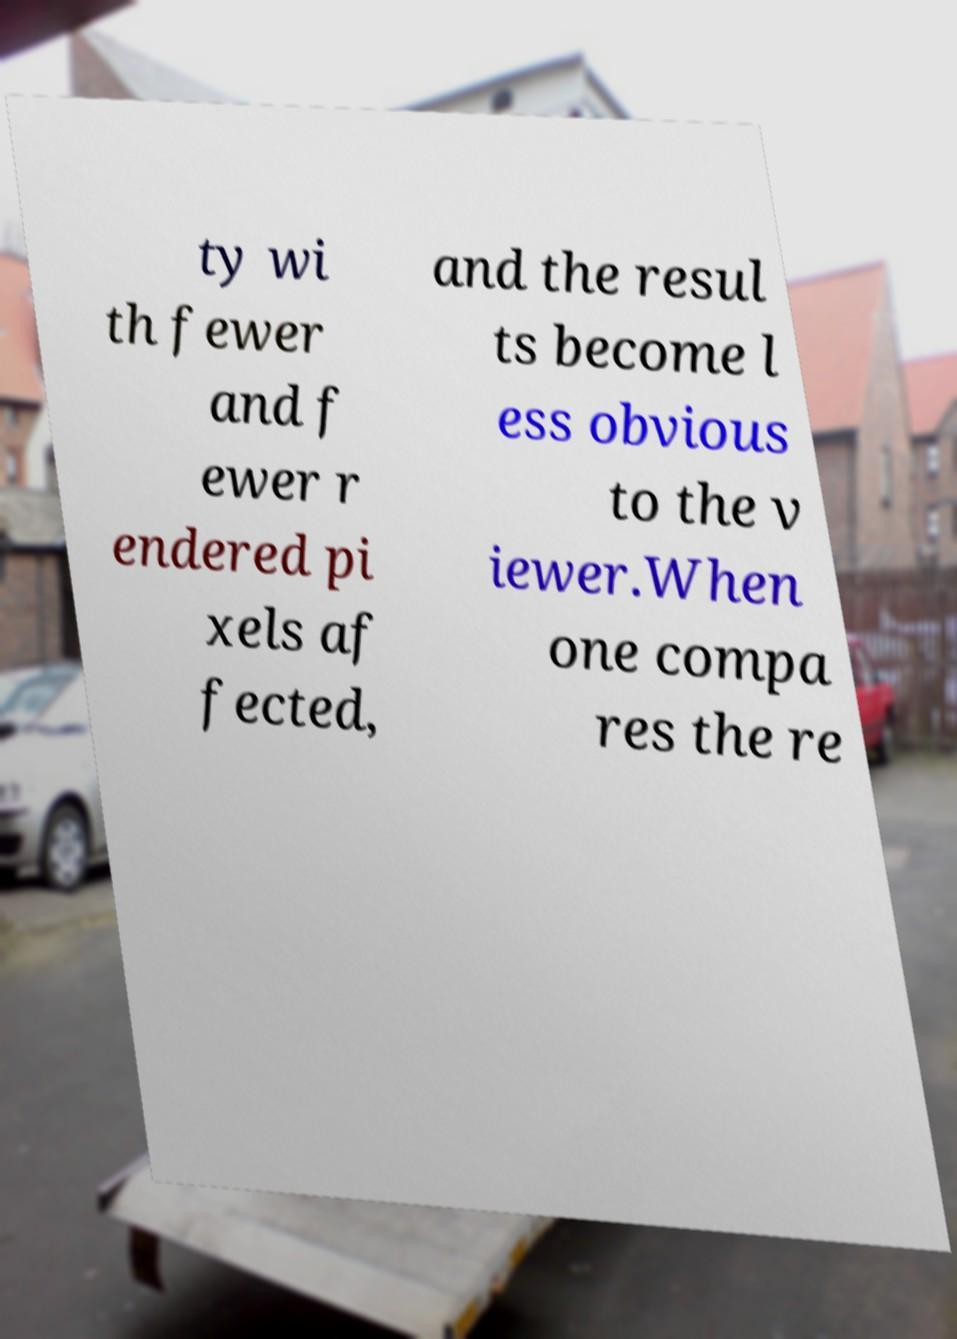Can you read and provide the text displayed in the image?This photo seems to have some interesting text. Can you extract and type it out for me? ty wi th fewer and f ewer r endered pi xels af fected, and the resul ts become l ess obvious to the v iewer.When one compa res the re 